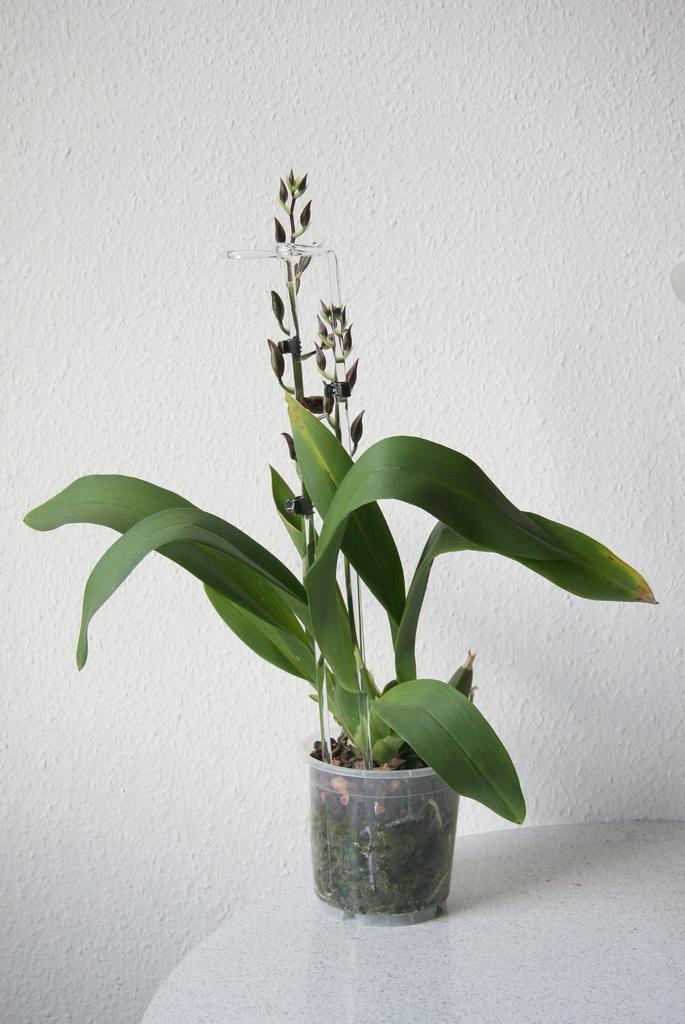Could you give a brief overview of what you see in this image? In this image, we can see a plant in a container is placed on the surface. We can also see the wall. 